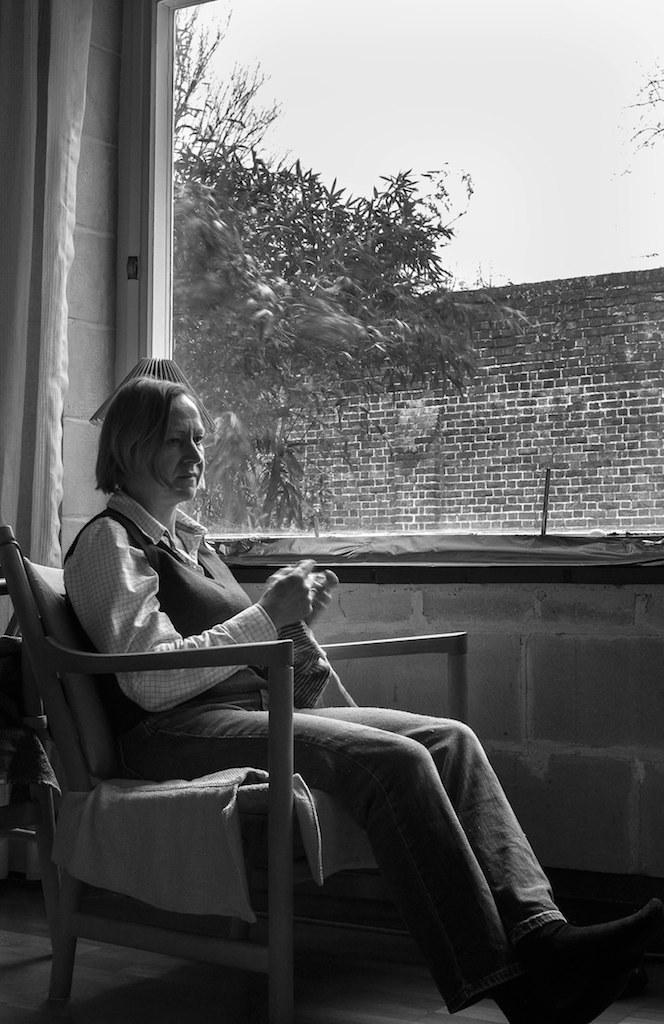What is the woman in the image doing? The woman is sitting on a chair in the image. What can be seen through the glass window? There is a tree visible in the image through the glass window. What is the background of the image made up of? The background of the image includes a wall. How many dimes are placed on the wall in the image? There are no dimes visible on the wall in the image. What type of system is being used to control the tree in the image? There is no system controlling the tree in the image; it is a natural, growing tree. 